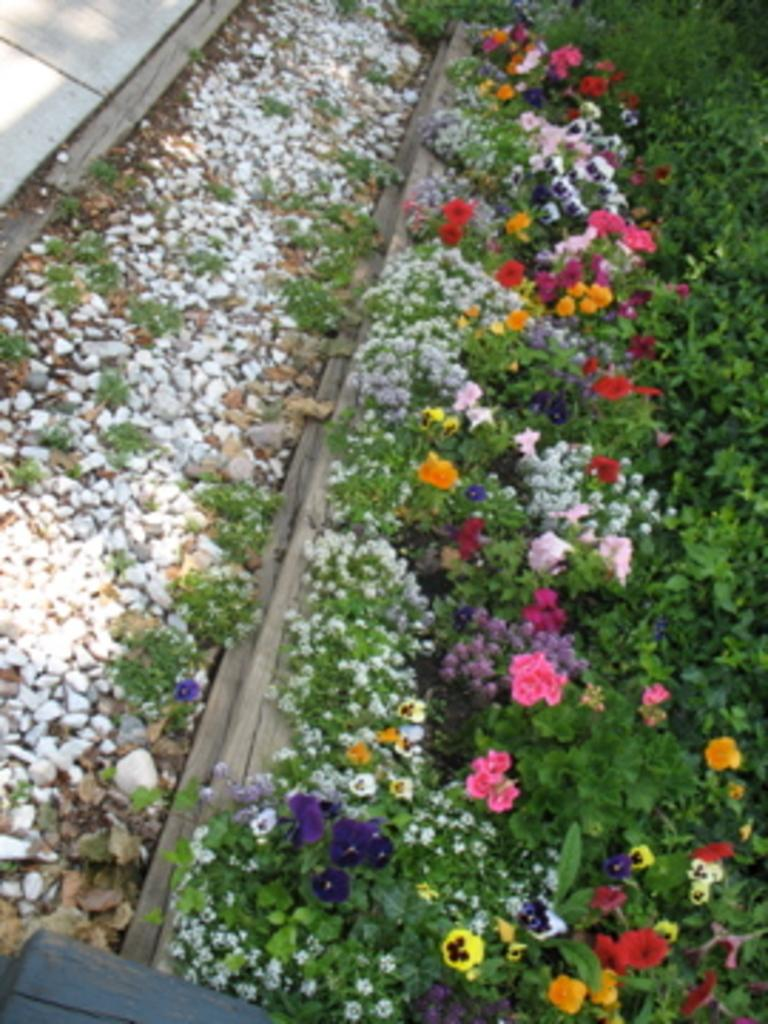What type of living organisms can be seen in the image? Flowers and plants are visible in the image. What other objects can be seen in the image besides living organisms? There are stones in the image. What type of watch can be seen on the flowers in the image? There is no watch present in the image; it features flowers, plants, and stones. What scent can be detected from the flowers in the image? The image does not provide information about the scent of the flowers, only their visual appearance. 